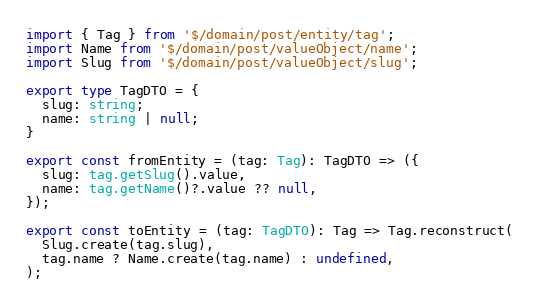<code> <loc_0><loc_0><loc_500><loc_500><_TypeScript_>import { Tag } from '$/domain/post/entity/tag';
import Name from '$/domain/post/valueObject/name';
import Slug from '$/domain/post/valueObject/slug';

export type TagDTO = {
  slug: string;
  name: string | null;
}

export const fromEntity = (tag: Tag): TagDTO => ({
  slug: tag.getSlug().value,
  name: tag.getName()?.value ?? null,
});

export const toEntity = (tag: TagDTO): Tag => Tag.reconstruct(
  Slug.create(tag.slug),
  tag.name ? Name.create(tag.name) : undefined,
);
</code> 